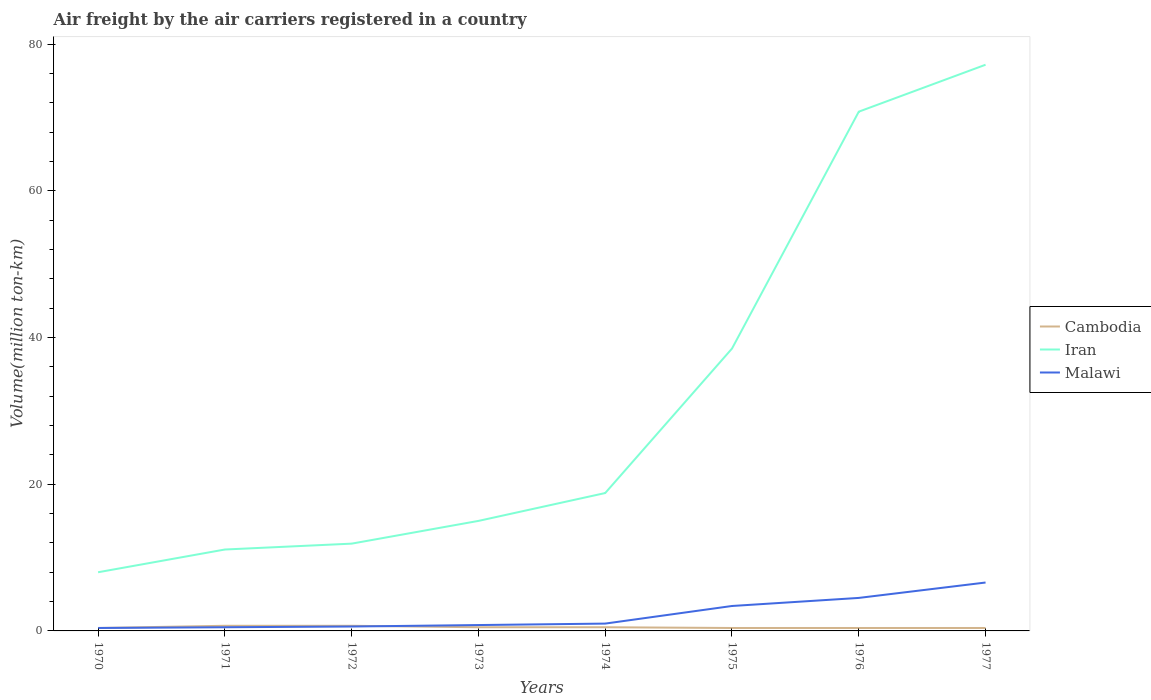Does the line corresponding to Malawi intersect with the line corresponding to Cambodia?
Keep it short and to the point. Yes. Is the number of lines equal to the number of legend labels?
Your response must be concise. Yes. Across all years, what is the maximum volume of the air carriers in Cambodia?
Your answer should be compact. 0.4. In which year was the volume of the air carriers in Iran maximum?
Provide a short and direct response. 1970. What is the total volume of the air carriers in Malawi in the graph?
Offer a very short reply. -3.9. What is the difference between the highest and the second highest volume of the air carriers in Iran?
Give a very brief answer. 69.2. Is the volume of the air carriers in Iran strictly greater than the volume of the air carriers in Cambodia over the years?
Ensure brevity in your answer.  No. How many lines are there?
Provide a short and direct response. 3. What is the difference between two consecutive major ticks on the Y-axis?
Your answer should be very brief. 20. Are the values on the major ticks of Y-axis written in scientific E-notation?
Offer a very short reply. No. Does the graph contain any zero values?
Make the answer very short. No. Where does the legend appear in the graph?
Give a very brief answer. Center right. How are the legend labels stacked?
Provide a short and direct response. Vertical. What is the title of the graph?
Offer a terse response. Air freight by the air carriers registered in a country. Does "East Asia (developing only)" appear as one of the legend labels in the graph?
Offer a very short reply. No. What is the label or title of the X-axis?
Ensure brevity in your answer.  Years. What is the label or title of the Y-axis?
Keep it short and to the point. Volume(million ton-km). What is the Volume(million ton-km) in Cambodia in 1970?
Offer a very short reply. 0.4. What is the Volume(million ton-km) of Iran in 1970?
Give a very brief answer. 8. What is the Volume(million ton-km) of Malawi in 1970?
Provide a succinct answer. 0.4. What is the Volume(million ton-km) in Cambodia in 1971?
Offer a terse response. 0.7. What is the Volume(million ton-km) in Iran in 1971?
Your answer should be very brief. 11.1. What is the Volume(million ton-km) of Cambodia in 1972?
Give a very brief answer. 0.7. What is the Volume(million ton-km) of Iran in 1972?
Make the answer very short. 11.9. What is the Volume(million ton-km) in Malawi in 1972?
Provide a short and direct response. 0.6. What is the Volume(million ton-km) of Malawi in 1973?
Offer a terse response. 0.8. What is the Volume(million ton-km) in Iran in 1974?
Your answer should be compact. 18.8. What is the Volume(million ton-km) in Malawi in 1974?
Your response must be concise. 1. What is the Volume(million ton-km) in Cambodia in 1975?
Give a very brief answer. 0.4. What is the Volume(million ton-km) of Iran in 1975?
Offer a very short reply. 38.5. What is the Volume(million ton-km) of Malawi in 1975?
Provide a succinct answer. 3.4. What is the Volume(million ton-km) in Cambodia in 1976?
Make the answer very short. 0.4. What is the Volume(million ton-km) of Iran in 1976?
Keep it short and to the point. 70.8. What is the Volume(million ton-km) of Malawi in 1976?
Offer a very short reply. 4.5. What is the Volume(million ton-km) of Cambodia in 1977?
Ensure brevity in your answer.  0.4. What is the Volume(million ton-km) of Iran in 1977?
Offer a very short reply. 77.2. What is the Volume(million ton-km) of Malawi in 1977?
Your answer should be very brief. 6.6. Across all years, what is the maximum Volume(million ton-km) of Cambodia?
Provide a short and direct response. 0.7. Across all years, what is the maximum Volume(million ton-km) in Iran?
Ensure brevity in your answer.  77.2. Across all years, what is the maximum Volume(million ton-km) of Malawi?
Provide a succinct answer. 6.6. Across all years, what is the minimum Volume(million ton-km) of Cambodia?
Provide a succinct answer. 0.4. Across all years, what is the minimum Volume(million ton-km) of Iran?
Keep it short and to the point. 8. Across all years, what is the minimum Volume(million ton-km) in Malawi?
Your response must be concise. 0.4. What is the total Volume(million ton-km) in Iran in the graph?
Provide a short and direct response. 251.3. What is the total Volume(million ton-km) of Malawi in the graph?
Provide a short and direct response. 17.8. What is the difference between the Volume(million ton-km) in Cambodia in 1970 and that in 1971?
Offer a terse response. -0.3. What is the difference between the Volume(million ton-km) of Iran in 1970 and that in 1971?
Keep it short and to the point. -3.1. What is the difference between the Volume(million ton-km) in Malawi in 1970 and that in 1971?
Your response must be concise. -0.1. What is the difference between the Volume(million ton-km) in Malawi in 1970 and that in 1972?
Give a very brief answer. -0.2. What is the difference between the Volume(million ton-km) of Iran in 1970 and that in 1973?
Your response must be concise. -7. What is the difference between the Volume(million ton-km) of Iran in 1970 and that in 1974?
Your answer should be very brief. -10.8. What is the difference between the Volume(million ton-km) of Cambodia in 1970 and that in 1975?
Your answer should be compact. 0. What is the difference between the Volume(million ton-km) in Iran in 1970 and that in 1975?
Provide a short and direct response. -30.5. What is the difference between the Volume(million ton-km) of Malawi in 1970 and that in 1975?
Provide a succinct answer. -3. What is the difference between the Volume(million ton-km) in Iran in 1970 and that in 1976?
Make the answer very short. -62.8. What is the difference between the Volume(million ton-km) of Malawi in 1970 and that in 1976?
Your answer should be compact. -4.1. What is the difference between the Volume(million ton-km) of Iran in 1970 and that in 1977?
Your answer should be very brief. -69.2. What is the difference between the Volume(million ton-km) in Malawi in 1970 and that in 1977?
Provide a short and direct response. -6.2. What is the difference between the Volume(million ton-km) of Malawi in 1971 and that in 1972?
Your response must be concise. -0.1. What is the difference between the Volume(million ton-km) in Cambodia in 1971 and that in 1974?
Keep it short and to the point. 0.2. What is the difference between the Volume(million ton-km) of Iran in 1971 and that in 1975?
Give a very brief answer. -27.4. What is the difference between the Volume(million ton-km) of Cambodia in 1971 and that in 1976?
Provide a succinct answer. 0.3. What is the difference between the Volume(million ton-km) in Iran in 1971 and that in 1976?
Ensure brevity in your answer.  -59.7. What is the difference between the Volume(million ton-km) in Malawi in 1971 and that in 1976?
Your response must be concise. -4. What is the difference between the Volume(million ton-km) of Iran in 1971 and that in 1977?
Make the answer very short. -66.1. What is the difference between the Volume(million ton-km) of Malawi in 1971 and that in 1977?
Provide a succinct answer. -6.1. What is the difference between the Volume(million ton-km) in Cambodia in 1972 and that in 1973?
Ensure brevity in your answer.  0.2. What is the difference between the Volume(million ton-km) in Iran in 1972 and that in 1973?
Offer a very short reply. -3.1. What is the difference between the Volume(million ton-km) in Iran in 1972 and that in 1974?
Offer a terse response. -6.9. What is the difference between the Volume(million ton-km) of Cambodia in 1972 and that in 1975?
Keep it short and to the point. 0.3. What is the difference between the Volume(million ton-km) of Iran in 1972 and that in 1975?
Provide a succinct answer. -26.6. What is the difference between the Volume(million ton-km) in Malawi in 1972 and that in 1975?
Your response must be concise. -2.8. What is the difference between the Volume(million ton-km) of Cambodia in 1972 and that in 1976?
Provide a succinct answer. 0.3. What is the difference between the Volume(million ton-km) in Iran in 1972 and that in 1976?
Provide a short and direct response. -58.9. What is the difference between the Volume(million ton-km) in Iran in 1972 and that in 1977?
Your answer should be very brief. -65.3. What is the difference between the Volume(million ton-km) of Malawi in 1972 and that in 1977?
Provide a short and direct response. -6. What is the difference between the Volume(million ton-km) in Cambodia in 1973 and that in 1974?
Provide a short and direct response. 0. What is the difference between the Volume(million ton-km) in Malawi in 1973 and that in 1974?
Offer a terse response. -0.2. What is the difference between the Volume(million ton-km) of Iran in 1973 and that in 1975?
Your response must be concise. -23.5. What is the difference between the Volume(million ton-km) of Malawi in 1973 and that in 1975?
Your response must be concise. -2.6. What is the difference between the Volume(million ton-km) in Iran in 1973 and that in 1976?
Your answer should be compact. -55.8. What is the difference between the Volume(million ton-km) of Malawi in 1973 and that in 1976?
Provide a short and direct response. -3.7. What is the difference between the Volume(million ton-km) in Cambodia in 1973 and that in 1977?
Your response must be concise. 0.1. What is the difference between the Volume(million ton-km) in Iran in 1973 and that in 1977?
Ensure brevity in your answer.  -62.2. What is the difference between the Volume(million ton-km) of Malawi in 1973 and that in 1977?
Make the answer very short. -5.8. What is the difference between the Volume(million ton-km) of Iran in 1974 and that in 1975?
Your answer should be very brief. -19.7. What is the difference between the Volume(million ton-km) in Malawi in 1974 and that in 1975?
Give a very brief answer. -2.4. What is the difference between the Volume(million ton-km) in Cambodia in 1974 and that in 1976?
Provide a succinct answer. 0.1. What is the difference between the Volume(million ton-km) of Iran in 1974 and that in 1976?
Make the answer very short. -52. What is the difference between the Volume(million ton-km) of Iran in 1974 and that in 1977?
Provide a short and direct response. -58.4. What is the difference between the Volume(million ton-km) of Cambodia in 1975 and that in 1976?
Your answer should be very brief. 0. What is the difference between the Volume(million ton-km) of Iran in 1975 and that in 1976?
Your response must be concise. -32.3. What is the difference between the Volume(million ton-km) in Iran in 1975 and that in 1977?
Ensure brevity in your answer.  -38.7. What is the difference between the Volume(million ton-km) of Iran in 1976 and that in 1977?
Your answer should be compact. -6.4. What is the difference between the Volume(million ton-km) in Cambodia in 1970 and the Volume(million ton-km) in Malawi in 1971?
Provide a succinct answer. -0.1. What is the difference between the Volume(million ton-km) of Iran in 1970 and the Volume(million ton-km) of Malawi in 1971?
Your answer should be very brief. 7.5. What is the difference between the Volume(million ton-km) of Cambodia in 1970 and the Volume(million ton-km) of Iran in 1973?
Provide a short and direct response. -14.6. What is the difference between the Volume(million ton-km) in Cambodia in 1970 and the Volume(million ton-km) in Malawi in 1973?
Make the answer very short. -0.4. What is the difference between the Volume(million ton-km) in Cambodia in 1970 and the Volume(million ton-km) in Iran in 1974?
Keep it short and to the point. -18.4. What is the difference between the Volume(million ton-km) of Cambodia in 1970 and the Volume(million ton-km) of Malawi in 1974?
Provide a succinct answer. -0.6. What is the difference between the Volume(million ton-km) of Iran in 1970 and the Volume(million ton-km) of Malawi in 1974?
Give a very brief answer. 7. What is the difference between the Volume(million ton-km) in Cambodia in 1970 and the Volume(million ton-km) in Iran in 1975?
Keep it short and to the point. -38.1. What is the difference between the Volume(million ton-km) in Iran in 1970 and the Volume(million ton-km) in Malawi in 1975?
Offer a very short reply. 4.6. What is the difference between the Volume(million ton-km) of Cambodia in 1970 and the Volume(million ton-km) of Iran in 1976?
Offer a terse response. -70.4. What is the difference between the Volume(million ton-km) of Cambodia in 1970 and the Volume(million ton-km) of Iran in 1977?
Provide a succinct answer. -76.8. What is the difference between the Volume(million ton-km) in Cambodia in 1970 and the Volume(million ton-km) in Malawi in 1977?
Provide a short and direct response. -6.2. What is the difference between the Volume(million ton-km) of Iran in 1970 and the Volume(million ton-km) of Malawi in 1977?
Offer a very short reply. 1.4. What is the difference between the Volume(million ton-km) in Cambodia in 1971 and the Volume(million ton-km) in Iran in 1972?
Offer a very short reply. -11.2. What is the difference between the Volume(million ton-km) of Cambodia in 1971 and the Volume(million ton-km) of Malawi in 1972?
Offer a very short reply. 0.1. What is the difference between the Volume(million ton-km) of Cambodia in 1971 and the Volume(million ton-km) of Iran in 1973?
Offer a terse response. -14.3. What is the difference between the Volume(million ton-km) in Cambodia in 1971 and the Volume(million ton-km) in Malawi in 1973?
Provide a short and direct response. -0.1. What is the difference between the Volume(million ton-km) in Cambodia in 1971 and the Volume(million ton-km) in Iran in 1974?
Give a very brief answer. -18.1. What is the difference between the Volume(million ton-km) of Cambodia in 1971 and the Volume(million ton-km) of Malawi in 1974?
Your answer should be compact. -0.3. What is the difference between the Volume(million ton-km) of Iran in 1971 and the Volume(million ton-km) of Malawi in 1974?
Give a very brief answer. 10.1. What is the difference between the Volume(million ton-km) in Cambodia in 1971 and the Volume(million ton-km) in Iran in 1975?
Offer a terse response. -37.8. What is the difference between the Volume(million ton-km) of Cambodia in 1971 and the Volume(million ton-km) of Malawi in 1975?
Provide a short and direct response. -2.7. What is the difference between the Volume(million ton-km) in Iran in 1971 and the Volume(million ton-km) in Malawi in 1975?
Make the answer very short. 7.7. What is the difference between the Volume(million ton-km) of Cambodia in 1971 and the Volume(million ton-km) of Iran in 1976?
Offer a very short reply. -70.1. What is the difference between the Volume(million ton-km) in Iran in 1971 and the Volume(million ton-km) in Malawi in 1976?
Offer a very short reply. 6.6. What is the difference between the Volume(million ton-km) in Cambodia in 1971 and the Volume(million ton-km) in Iran in 1977?
Your answer should be compact. -76.5. What is the difference between the Volume(million ton-km) of Iran in 1971 and the Volume(million ton-km) of Malawi in 1977?
Your answer should be compact. 4.5. What is the difference between the Volume(million ton-km) of Cambodia in 1972 and the Volume(million ton-km) of Iran in 1973?
Give a very brief answer. -14.3. What is the difference between the Volume(million ton-km) of Cambodia in 1972 and the Volume(million ton-km) of Malawi in 1973?
Provide a short and direct response. -0.1. What is the difference between the Volume(million ton-km) of Iran in 1972 and the Volume(million ton-km) of Malawi in 1973?
Your answer should be very brief. 11.1. What is the difference between the Volume(million ton-km) in Cambodia in 1972 and the Volume(million ton-km) in Iran in 1974?
Keep it short and to the point. -18.1. What is the difference between the Volume(million ton-km) of Cambodia in 1972 and the Volume(million ton-km) of Iran in 1975?
Offer a very short reply. -37.8. What is the difference between the Volume(million ton-km) of Iran in 1972 and the Volume(million ton-km) of Malawi in 1975?
Provide a succinct answer. 8.5. What is the difference between the Volume(million ton-km) of Cambodia in 1972 and the Volume(million ton-km) of Iran in 1976?
Keep it short and to the point. -70.1. What is the difference between the Volume(million ton-km) of Cambodia in 1972 and the Volume(million ton-km) of Malawi in 1976?
Offer a very short reply. -3.8. What is the difference between the Volume(million ton-km) of Cambodia in 1972 and the Volume(million ton-km) of Iran in 1977?
Keep it short and to the point. -76.5. What is the difference between the Volume(million ton-km) of Iran in 1972 and the Volume(million ton-km) of Malawi in 1977?
Your response must be concise. 5.3. What is the difference between the Volume(million ton-km) in Cambodia in 1973 and the Volume(million ton-km) in Iran in 1974?
Your answer should be compact. -18.3. What is the difference between the Volume(million ton-km) in Cambodia in 1973 and the Volume(million ton-km) in Malawi in 1974?
Keep it short and to the point. -0.5. What is the difference between the Volume(million ton-km) of Cambodia in 1973 and the Volume(million ton-km) of Iran in 1975?
Your answer should be compact. -38. What is the difference between the Volume(million ton-km) of Cambodia in 1973 and the Volume(million ton-km) of Iran in 1976?
Keep it short and to the point. -70.3. What is the difference between the Volume(million ton-km) of Cambodia in 1973 and the Volume(million ton-km) of Malawi in 1976?
Provide a short and direct response. -4. What is the difference between the Volume(million ton-km) in Iran in 1973 and the Volume(million ton-km) in Malawi in 1976?
Provide a succinct answer. 10.5. What is the difference between the Volume(million ton-km) in Cambodia in 1973 and the Volume(million ton-km) in Iran in 1977?
Offer a terse response. -76.7. What is the difference between the Volume(million ton-km) in Cambodia in 1973 and the Volume(million ton-km) in Malawi in 1977?
Offer a terse response. -6.1. What is the difference between the Volume(million ton-km) in Iran in 1973 and the Volume(million ton-km) in Malawi in 1977?
Make the answer very short. 8.4. What is the difference between the Volume(million ton-km) in Cambodia in 1974 and the Volume(million ton-km) in Iran in 1975?
Make the answer very short. -38. What is the difference between the Volume(million ton-km) in Cambodia in 1974 and the Volume(million ton-km) in Malawi in 1975?
Offer a very short reply. -2.9. What is the difference between the Volume(million ton-km) in Iran in 1974 and the Volume(million ton-km) in Malawi in 1975?
Ensure brevity in your answer.  15.4. What is the difference between the Volume(million ton-km) in Cambodia in 1974 and the Volume(million ton-km) in Iran in 1976?
Offer a terse response. -70.3. What is the difference between the Volume(million ton-km) in Iran in 1974 and the Volume(million ton-km) in Malawi in 1976?
Your answer should be compact. 14.3. What is the difference between the Volume(million ton-km) of Cambodia in 1974 and the Volume(million ton-km) of Iran in 1977?
Make the answer very short. -76.7. What is the difference between the Volume(million ton-km) in Iran in 1974 and the Volume(million ton-km) in Malawi in 1977?
Provide a succinct answer. 12.2. What is the difference between the Volume(million ton-km) in Cambodia in 1975 and the Volume(million ton-km) in Iran in 1976?
Give a very brief answer. -70.4. What is the difference between the Volume(million ton-km) of Iran in 1975 and the Volume(million ton-km) of Malawi in 1976?
Make the answer very short. 34. What is the difference between the Volume(million ton-km) of Cambodia in 1975 and the Volume(million ton-km) of Iran in 1977?
Your response must be concise. -76.8. What is the difference between the Volume(million ton-km) of Iran in 1975 and the Volume(million ton-km) of Malawi in 1977?
Provide a short and direct response. 31.9. What is the difference between the Volume(million ton-km) in Cambodia in 1976 and the Volume(million ton-km) in Iran in 1977?
Offer a terse response. -76.8. What is the difference between the Volume(million ton-km) in Iran in 1976 and the Volume(million ton-km) in Malawi in 1977?
Give a very brief answer. 64.2. What is the average Volume(million ton-km) in Iran per year?
Make the answer very short. 31.41. What is the average Volume(million ton-km) of Malawi per year?
Your response must be concise. 2.23. In the year 1970, what is the difference between the Volume(million ton-km) in Iran and Volume(million ton-km) in Malawi?
Your answer should be compact. 7.6. In the year 1971, what is the difference between the Volume(million ton-km) of Cambodia and Volume(million ton-km) of Iran?
Your answer should be compact. -10.4. In the year 1971, what is the difference between the Volume(million ton-km) of Iran and Volume(million ton-km) of Malawi?
Make the answer very short. 10.6. In the year 1973, what is the difference between the Volume(million ton-km) in Cambodia and Volume(million ton-km) in Malawi?
Your answer should be very brief. -0.3. In the year 1973, what is the difference between the Volume(million ton-km) of Iran and Volume(million ton-km) of Malawi?
Offer a terse response. 14.2. In the year 1974, what is the difference between the Volume(million ton-km) of Cambodia and Volume(million ton-km) of Iran?
Your answer should be very brief. -18.3. In the year 1975, what is the difference between the Volume(million ton-km) of Cambodia and Volume(million ton-km) of Iran?
Provide a short and direct response. -38.1. In the year 1975, what is the difference between the Volume(million ton-km) in Cambodia and Volume(million ton-km) in Malawi?
Make the answer very short. -3. In the year 1975, what is the difference between the Volume(million ton-km) of Iran and Volume(million ton-km) of Malawi?
Your response must be concise. 35.1. In the year 1976, what is the difference between the Volume(million ton-km) of Cambodia and Volume(million ton-km) of Iran?
Your response must be concise. -70.4. In the year 1976, what is the difference between the Volume(million ton-km) of Iran and Volume(million ton-km) of Malawi?
Give a very brief answer. 66.3. In the year 1977, what is the difference between the Volume(million ton-km) in Cambodia and Volume(million ton-km) in Iran?
Keep it short and to the point. -76.8. In the year 1977, what is the difference between the Volume(million ton-km) of Cambodia and Volume(million ton-km) of Malawi?
Offer a terse response. -6.2. In the year 1977, what is the difference between the Volume(million ton-km) of Iran and Volume(million ton-km) of Malawi?
Your answer should be compact. 70.6. What is the ratio of the Volume(million ton-km) in Cambodia in 1970 to that in 1971?
Your answer should be compact. 0.57. What is the ratio of the Volume(million ton-km) in Iran in 1970 to that in 1971?
Provide a succinct answer. 0.72. What is the ratio of the Volume(million ton-km) in Iran in 1970 to that in 1972?
Your response must be concise. 0.67. What is the ratio of the Volume(million ton-km) in Malawi in 1970 to that in 1972?
Ensure brevity in your answer.  0.67. What is the ratio of the Volume(million ton-km) of Iran in 1970 to that in 1973?
Your response must be concise. 0.53. What is the ratio of the Volume(million ton-km) of Cambodia in 1970 to that in 1974?
Offer a very short reply. 0.8. What is the ratio of the Volume(million ton-km) of Iran in 1970 to that in 1974?
Make the answer very short. 0.43. What is the ratio of the Volume(million ton-km) of Malawi in 1970 to that in 1974?
Offer a terse response. 0.4. What is the ratio of the Volume(million ton-km) of Cambodia in 1970 to that in 1975?
Ensure brevity in your answer.  1. What is the ratio of the Volume(million ton-km) in Iran in 1970 to that in 1975?
Provide a short and direct response. 0.21. What is the ratio of the Volume(million ton-km) in Malawi in 1970 to that in 1975?
Offer a very short reply. 0.12. What is the ratio of the Volume(million ton-km) of Iran in 1970 to that in 1976?
Your response must be concise. 0.11. What is the ratio of the Volume(million ton-km) of Malawi in 1970 to that in 1976?
Offer a terse response. 0.09. What is the ratio of the Volume(million ton-km) of Iran in 1970 to that in 1977?
Offer a very short reply. 0.1. What is the ratio of the Volume(million ton-km) in Malawi in 1970 to that in 1977?
Your answer should be very brief. 0.06. What is the ratio of the Volume(million ton-km) in Iran in 1971 to that in 1972?
Make the answer very short. 0.93. What is the ratio of the Volume(million ton-km) of Malawi in 1971 to that in 1972?
Keep it short and to the point. 0.83. What is the ratio of the Volume(million ton-km) of Iran in 1971 to that in 1973?
Offer a terse response. 0.74. What is the ratio of the Volume(million ton-km) in Cambodia in 1971 to that in 1974?
Provide a short and direct response. 1.4. What is the ratio of the Volume(million ton-km) of Iran in 1971 to that in 1974?
Ensure brevity in your answer.  0.59. What is the ratio of the Volume(million ton-km) in Malawi in 1971 to that in 1974?
Your response must be concise. 0.5. What is the ratio of the Volume(million ton-km) of Iran in 1971 to that in 1975?
Ensure brevity in your answer.  0.29. What is the ratio of the Volume(million ton-km) of Malawi in 1971 to that in 1975?
Provide a succinct answer. 0.15. What is the ratio of the Volume(million ton-km) in Cambodia in 1971 to that in 1976?
Make the answer very short. 1.75. What is the ratio of the Volume(million ton-km) in Iran in 1971 to that in 1976?
Provide a short and direct response. 0.16. What is the ratio of the Volume(million ton-km) of Cambodia in 1971 to that in 1977?
Offer a terse response. 1.75. What is the ratio of the Volume(million ton-km) of Iran in 1971 to that in 1977?
Offer a terse response. 0.14. What is the ratio of the Volume(million ton-km) in Malawi in 1971 to that in 1977?
Your answer should be very brief. 0.08. What is the ratio of the Volume(million ton-km) in Cambodia in 1972 to that in 1973?
Provide a succinct answer. 1.4. What is the ratio of the Volume(million ton-km) in Iran in 1972 to that in 1973?
Ensure brevity in your answer.  0.79. What is the ratio of the Volume(million ton-km) of Malawi in 1972 to that in 1973?
Provide a short and direct response. 0.75. What is the ratio of the Volume(million ton-km) in Iran in 1972 to that in 1974?
Provide a short and direct response. 0.63. What is the ratio of the Volume(million ton-km) in Iran in 1972 to that in 1975?
Make the answer very short. 0.31. What is the ratio of the Volume(million ton-km) of Malawi in 1972 to that in 1975?
Make the answer very short. 0.18. What is the ratio of the Volume(million ton-km) in Iran in 1972 to that in 1976?
Your answer should be compact. 0.17. What is the ratio of the Volume(million ton-km) in Malawi in 1972 to that in 1976?
Ensure brevity in your answer.  0.13. What is the ratio of the Volume(million ton-km) of Iran in 1972 to that in 1977?
Ensure brevity in your answer.  0.15. What is the ratio of the Volume(million ton-km) of Malawi in 1972 to that in 1977?
Ensure brevity in your answer.  0.09. What is the ratio of the Volume(million ton-km) of Cambodia in 1973 to that in 1974?
Keep it short and to the point. 1. What is the ratio of the Volume(million ton-km) in Iran in 1973 to that in 1974?
Your answer should be compact. 0.8. What is the ratio of the Volume(million ton-km) in Malawi in 1973 to that in 1974?
Offer a very short reply. 0.8. What is the ratio of the Volume(million ton-km) in Iran in 1973 to that in 1975?
Your answer should be very brief. 0.39. What is the ratio of the Volume(million ton-km) in Malawi in 1973 to that in 1975?
Make the answer very short. 0.24. What is the ratio of the Volume(million ton-km) in Iran in 1973 to that in 1976?
Make the answer very short. 0.21. What is the ratio of the Volume(million ton-km) in Malawi in 1973 to that in 1976?
Your response must be concise. 0.18. What is the ratio of the Volume(million ton-km) in Iran in 1973 to that in 1977?
Offer a terse response. 0.19. What is the ratio of the Volume(million ton-km) in Malawi in 1973 to that in 1977?
Provide a succinct answer. 0.12. What is the ratio of the Volume(million ton-km) in Iran in 1974 to that in 1975?
Offer a terse response. 0.49. What is the ratio of the Volume(million ton-km) of Malawi in 1974 to that in 1975?
Give a very brief answer. 0.29. What is the ratio of the Volume(million ton-km) of Cambodia in 1974 to that in 1976?
Offer a terse response. 1.25. What is the ratio of the Volume(million ton-km) in Iran in 1974 to that in 1976?
Ensure brevity in your answer.  0.27. What is the ratio of the Volume(million ton-km) in Malawi in 1974 to that in 1976?
Your answer should be compact. 0.22. What is the ratio of the Volume(million ton-km) of Cambodia in 1974 to that in 1977?
Keep it short and to the point. 1.25. What is the ratio of the Volume(million ton-km) in Iran in 1974 to that in 1977?
Your answer should be compact. 0.24. What is the ratio of the Volume(million ton-km) in Malawi in 1974 to that in 1977?
Offer a very short reply. 0.15. What is the ratio of the Volume(million ton-km) in Iran in 1975 to that in 1976?
Make the answer very short. 0.54. What is the ratio of the Volume(million ton-km) of Malawi in 1975 to that in 1976?
Keep it short and to the point. 0.76. What is the ratio of the Volume(million ton-km) of Cambodia in 1975 to that in 1977?
Your answer should be very brief. 1. What is the ratio of the Volume(million ton-km) in Iran in 1975 to that in 1977?
Ensure brevity in your answer.  0.5. What is the ratio of the Volume(million ton-km) of Malawi in 1975 to that in 1977?
Your answer should be compact. 0.52. What is the ratio of the Volume(million ton-km) of Iran in 1976 to that in 1977?
Provide a succinct answer. 0.92. What is the ratio of the Volume(million ton-km) of Malawi in 1976 to that in 1977?
Your response must be concise. 0.68. What is the difference between the highest and the second highest Volume(million ton-km) in Cambodia?
Provide a short and direct response. 0. What is the difference between the highest and the second highest Volume(million ton-km) of Iran?
Provide a short and direct response. 6.4. What is the difference between the highest and the second highest Volume(million ton-km) of Malawi?
Provide a succinct answer. 2.1. What is the difference between the highest and the lowest Volume(million ton-km) of Cambodia?
Offer a terse response. 0.3. What is the difference between the highest and the lowest Volume(million ton-km) of Iran?
Offer a very short reply. 69.2. What is the difference between the highest and the lowest Volume(million ton-km) in Malawi?
Ensure brevity in your answer.  6.2. 